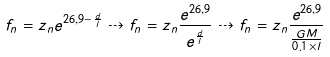Convert formula to latex. <formula><loc_0><loc_0><loc_500><loc_500>f _ { n } = z _ { n } e ^ { 2 6 , 9 - \frac { d } { l } } \dashrightarrow f _ { n } = z _ { n } \frac { e ^ { 2 6 , 9 } } { e ^ { \frac { d } { l } } } \dashrightarrow f _ { n } = z _ { n } \frac { e ^ { 2 6 , 9 } } { \frac { G M } { 0 . 1 \times l } }</formula> 